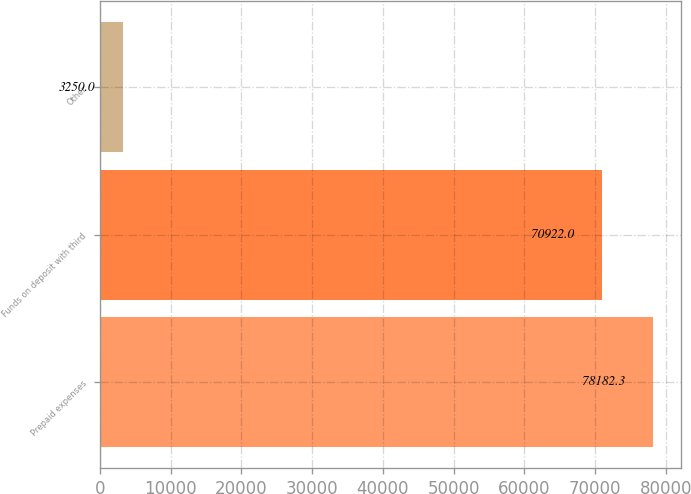Convert chart to OTSL. <chart><loc_0><loc_0><loc_500><loc_500><bar_chart><fcel>Prepaid expenses<fcel>Funds on deposit with third<fcel>Other<nl><fcel>78182.3<fcel>70922<fcel>3250<nl></chart> 